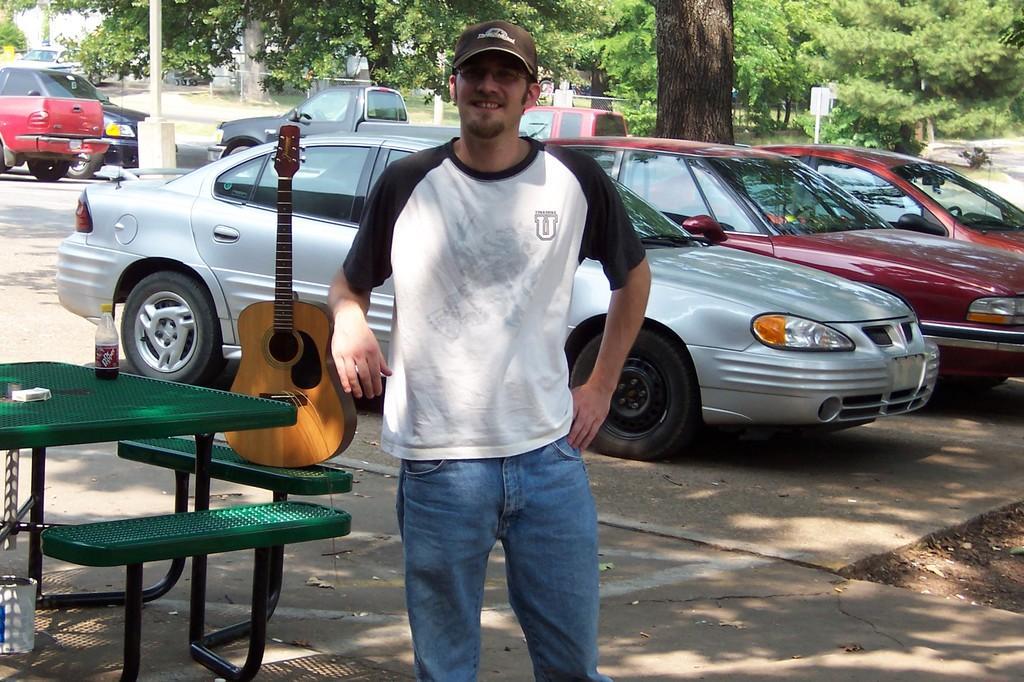In one or two sentences, can you explain what this image depicts? In the foreground of the picture there is a man in white t-shirt standing wearing a cap. On the left there is a bench on the bench there is a guitar and a drink bottle. In the background there are many cars and trees. 